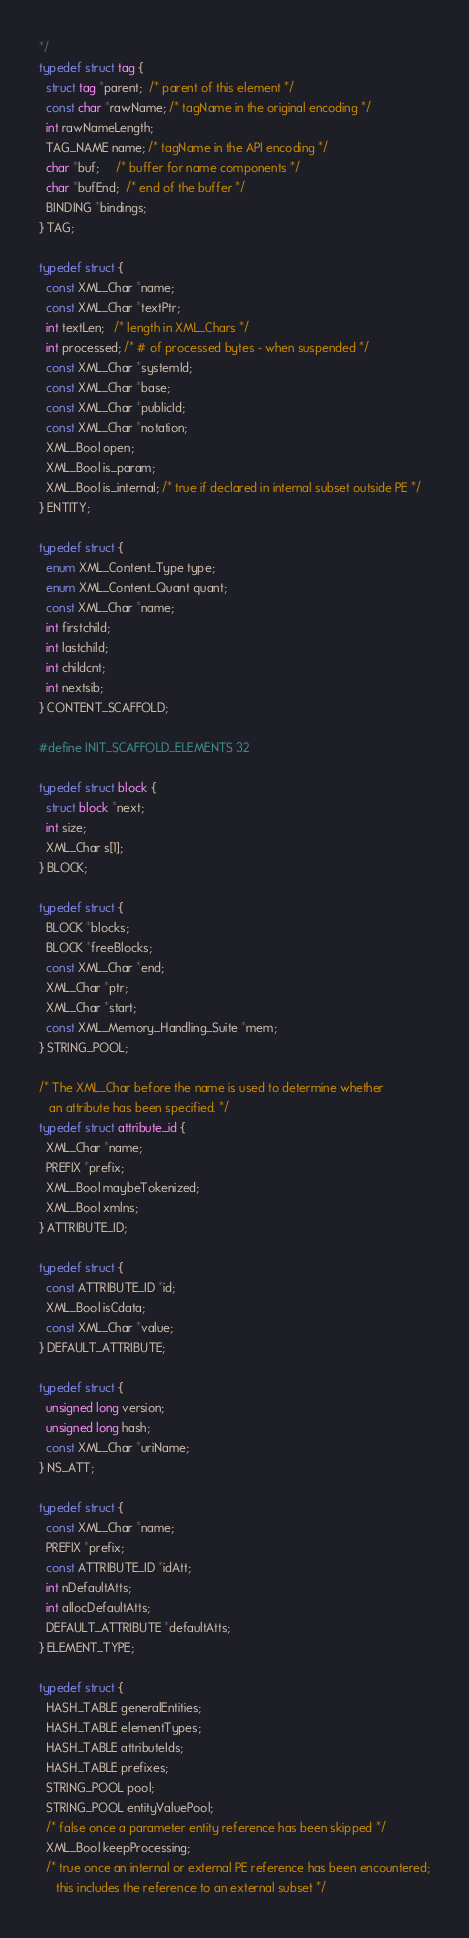Convert code to text. <code><loc_0><loc_0><loc_500><loc_500><_C_>*/
typedef struct tag {
  struct tag *parent;  /* parent of this element */
  const char *rawName; /* tagName in the original encoding */
  int rawNameLength;
  TAG_NAME name; /* tagName in the API encoding */
  char *buf;     /* buffer for name components */
  char *bufEnd;  /* end of the buffer */
  BINDING *bindings;
} TAG;

typedef struct {
  const XML_Char *name;
  const XML_Char *textPtr;
  int textLen;   /* length in XML_Chars */
  int processed; /* # of processed bytes - when suspended */
  const XML_Char *systemId;
  const XML_Char *base;
  const XML_Char *publicId;
  const XML_Char *notation;
  XML_Bool open;
  XML_Bool is_param;
  XML_Bool is_internal; /* true if declared in internal subset outside PE */
} ENTITY;

typedef struct {
  enum XML_Content_Type type;
  enum XML_Content_Quant quant;
  const XML_Char *name;
  int firstchild;
  int lastchild;
  int childcnt;
  int nextsib;
} CONTENT_SCAFFOLD;

#define INIT_SCAFFOLD_ELEMENTS 32

typedef struct block {
  struct block *next;
  int size;
  XML_Char s[1];
} BLOCK;

typedef struct {
  BLOCK *blocks;
  BLOCK *freeBlocks;
  const XML_Char *end;
  XML_Char *ptr;
  XML_Char *start;
  const XML_Memory_Handling_Suite *mem;
} STRING_POOL;

/* The XML_Char before the name is used to determine whether
   an attribute has been specified. */
typedef struct attribute_id {
  XML_Char *name;
  PREFIX *prefix;
  XML_Bool maybeTokenized;
  XML_Bool xmlns;
} ATTRIBUTE_ID;

typedef struct {
  const ATTRIBUTE_ID *id;
  XML_Bool isCdata;
  const XML_Char *value;
} DEFAULT_ATTRIBUTE;

typedef struct {
  unsigned long version;
  unsigned long hash;
  const XML_Char *uriName;
} NS_ATT;

typedef struct {
  const XML_Char *name;
  PREFIX *prefix;
  const ATTRIBUTE_ID *idAtt;
  int nDefaultAtts;
  int allocDefaultAtts;
  DEFAULT_ATTRIBUTE *defaultAtts;
} ELEMENT_TYPE;

typedef struct {
  HASH_TABLE generalEntities;
  HASH_TABLE elementTypes;
  HASH_TABLE attributeIds;
  HASH_TABLE prefixes;
  STRING_POOL pool;
  STRING_POOL entityValuePool;
  /* false once a parameter entity reference has been skipped */
  XML_Bool keepProcessing;
  /* true once an internal or external PE reference has been encountered;
     this includes the reference to an external subset */</code> 